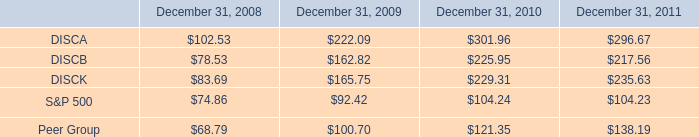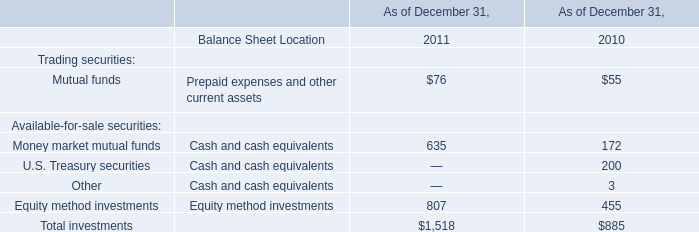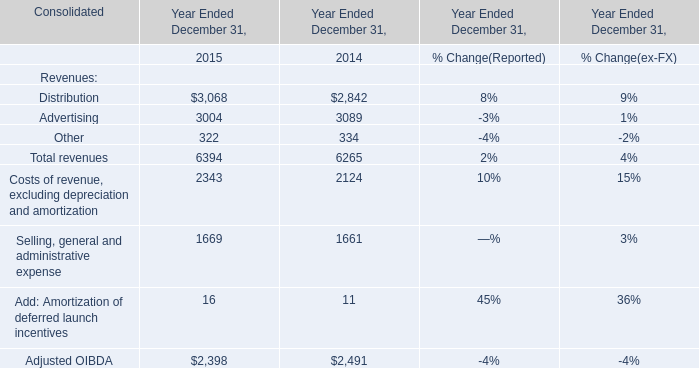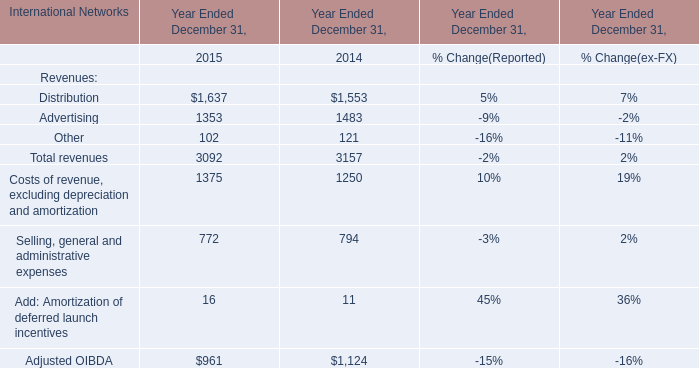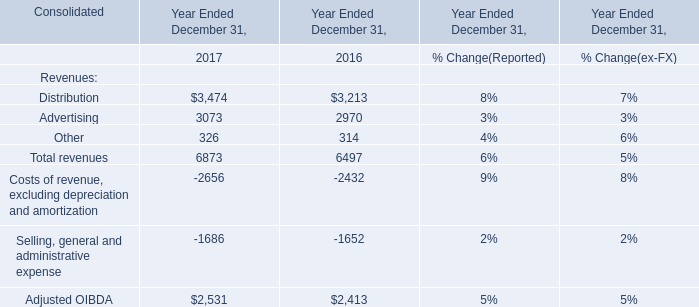What was the average value of Distribution, Advertising, Other in 2017? 
Computations: (6873 / 3)
Answer: 2291.0. 